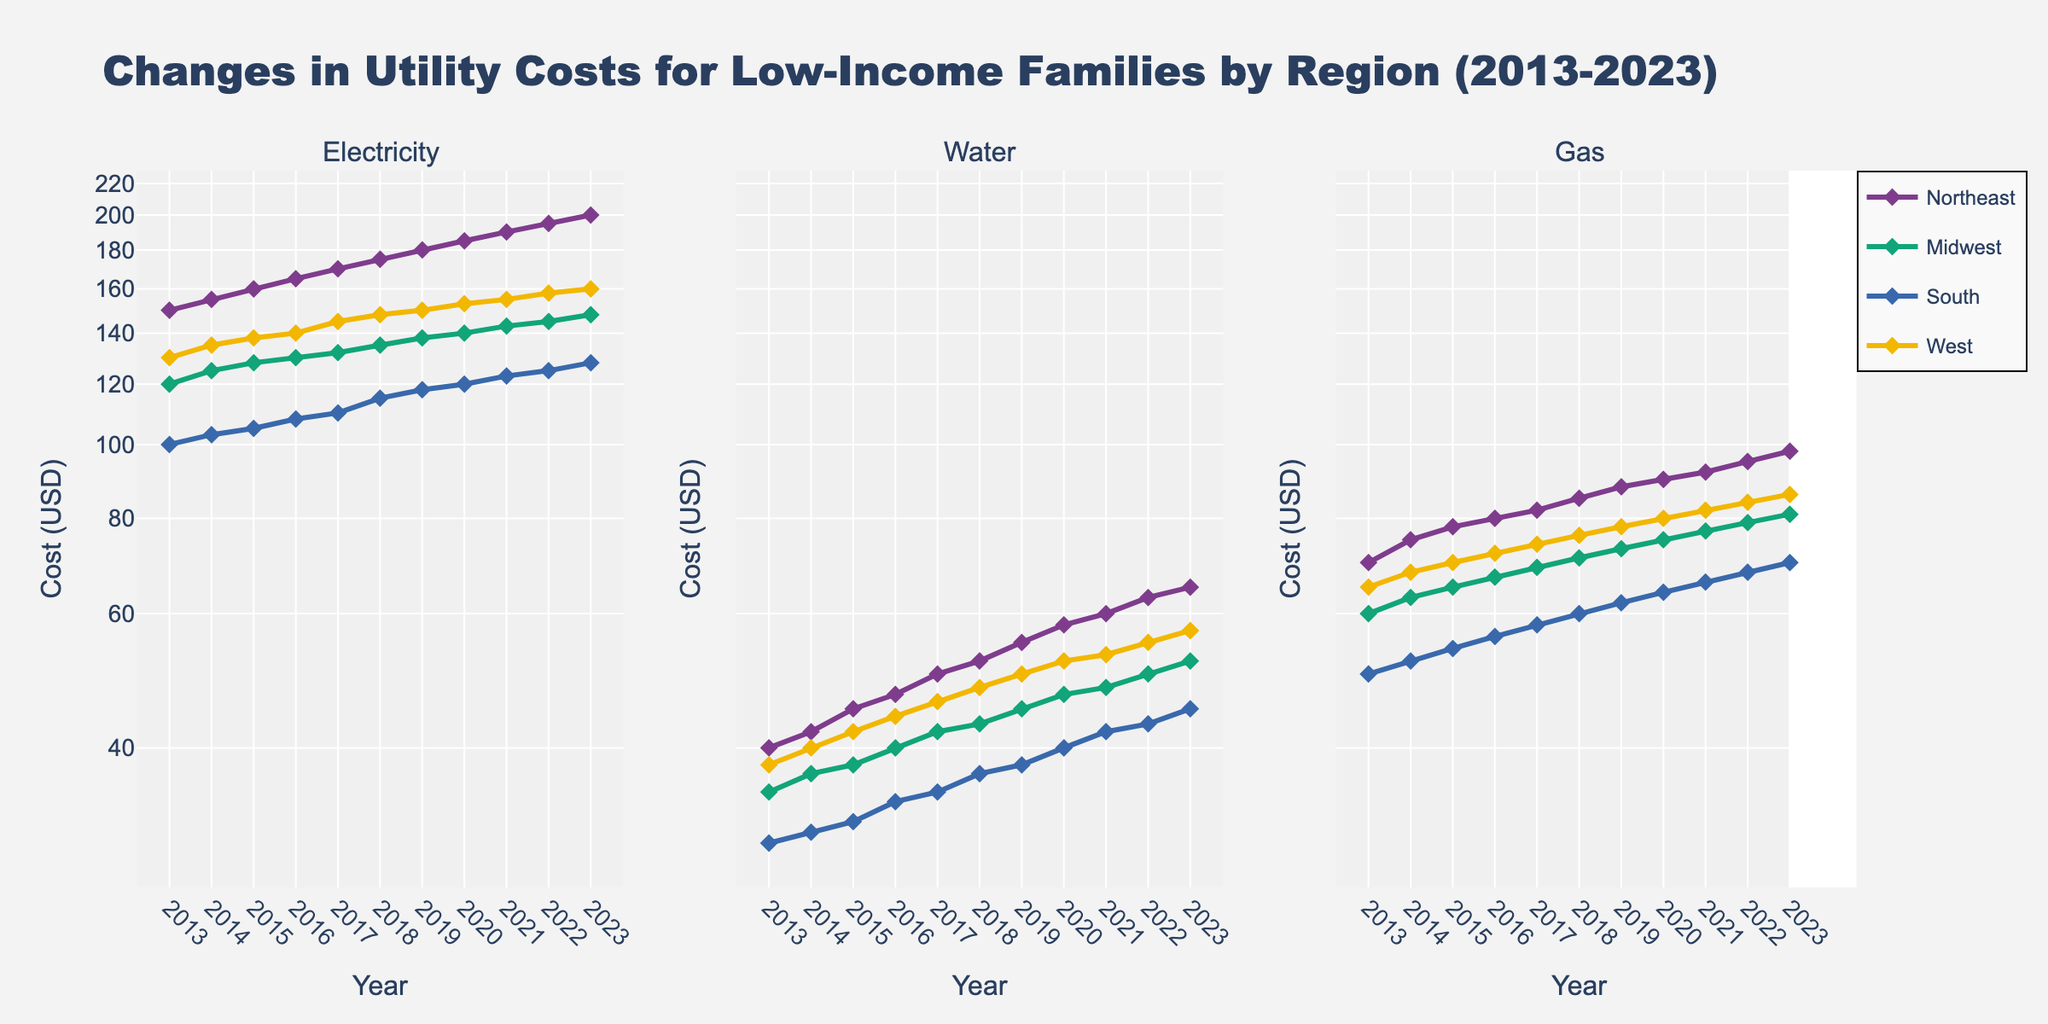What's the title of the figure? The title of the figure is found at the top and reads "Changes in Utility Costs for Low-Income Families by Region (2013-2023)."
Answer: Changes in Utility Costs for Low-Income Families by Region (2013-2023) What is the y-axis scale type for all subplots? The y-axis scale type for all subplots is indicated by the labels, which imply that it is a log scale by definition.
Answer: Log scale Which Region sees the highest Electricity Cost in 2023? To find the highest Electricity Cost in 2023, observe the line corresponding to 2023 for Electricity. The "Northeast" region is at the topmost point.
Answer: Northeast In which year was the Water Cost highest in the Midwest? The highest Water Cost for the Midwest in the subplot can be observed in the year 2023, as the line reaches its peak in this year.
Answer: 2023 By how much did the Gas Cost increase in the South from 2013 to 2023? From the Gas subplot, locate the South region at the start (2013) and end (2023). The Gas Cost increased from 50 to 70. Compute the difference: 70 - 50 = 20.
Answer: 20 Which Region had the lowest Water Cost in 2018? In the Water subplot, the South region is the lowest point in 2018.
Answer: South How does the trend of Electricity Costs in the West compare to the South? In the Electricity subplot, both the West and South show an upward trend, but the West consistently has higher values than the South across all years.
Answer: West higher than South Do Gas Costs appear to be increasing or decreasing over the decade for all regions? Across all regions in the Gas subplot, the lines indicate an overall upward trend from 2013 to 2023, suggesting an increase in Gas Costs.
Answer: Increasing Which region has the sharpest increase in Electricity Cost? Looking at the slope of the Electricity Cost lines, the Northeast region exhibits the steepest increase over the decade.
Answer: Northeast What's the approximate average increase in Water Costs for the West from 2013 to 2023? First, identify the Water Costs for the West in 2013 (38) and 2023 (57). Compute the increase (57 - 38 = 19). The average increase per year over 10 years is 19/10 = 1.9.
Answer: 1.9 